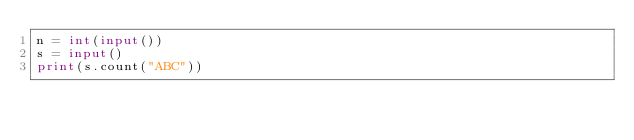Convert code to text. <code><loc_0><loc_0><loc_500><loc_500><_Python_>n = int(input())
s = input()
print(s.count("ABC"))
</code> 